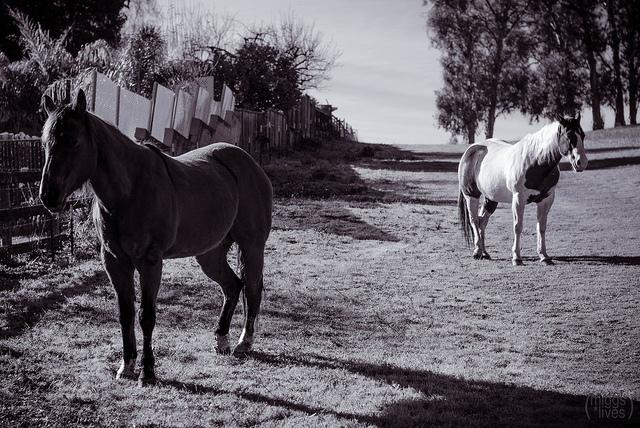What color is the horse?
Keep it brief. Brown. What color are the horses?
Answer briefly. White and brown. Are the horses walking?
Give a very brief answer. No. Are they on a farm?
Short answer required. Yes. Are these horses mother and daughter?
Keep it brief. No. What color is the horse in the back?
Give a very brief answer. White and brown. What color is the first horse?
Concise answer only. Brown. How many horses are walking on the road?
Write a very short answer. 2. Is the animal giraffe?
Keep it brief. No. Is the photo in color?
Answer briefly. No. 